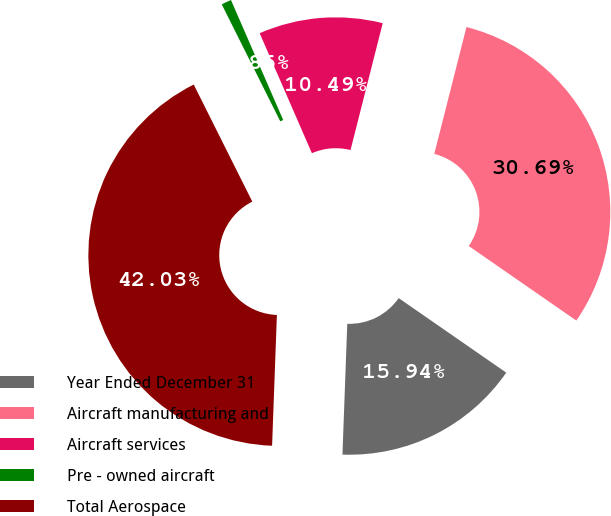Convert chart to OTSL. <chart><loc_0><loc_0><loc_500><loc_500><pie_chart><fcel>Year Ended December 31<fcel>Aircraft manufacturing and<fcel>Aircraft services<fcel>Pre - owned aircraft<fcel>Total Aerospace<nl><fcel>15.94%<fcel>30.69%<fcel>10.49%<fcel>0.85%<fcel>42.03%<nl></chart> 